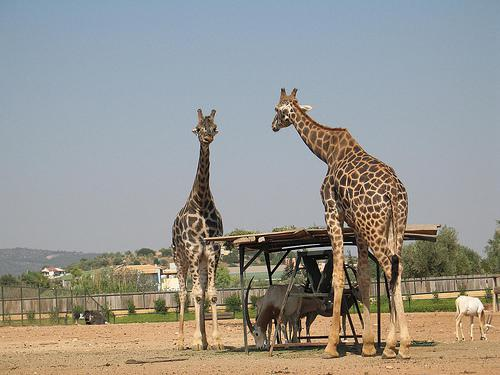Question: what is the ground covered in?
Choices:
A. Dirt.
B. Grass.
C. Gravel.
D. AstroTurf.
Answer with the letter. Answer: A Question: why is there a shelter?
Choices:
A. To protect against rain.
B. To protect against wind.
C. For shade.
D. To hold gear.
Answer with the letter. Answer: C Question: what are the giraffes doing?
Choices:
A. Eating.
B. Standing.
C. Drinking.
D. Sleeping.
Answer with the letter. Answer: B Question: what is the fence for?
Choices:
A. Looks.
B. Protection.
C. Containment.
D. Regulations.
Answer with the letter. Answer: C Question: what color are the goats?
Choices:
A. Brown.
B. Black.
C. Gray.
D. White.
Answer with the letter. Answer: D Question: when was this picture taken?
Choices:
A. Daytime.
B. Nighttime.
C. Sunset.
D. Sunrise.
Answer with the letter. Answer: A 